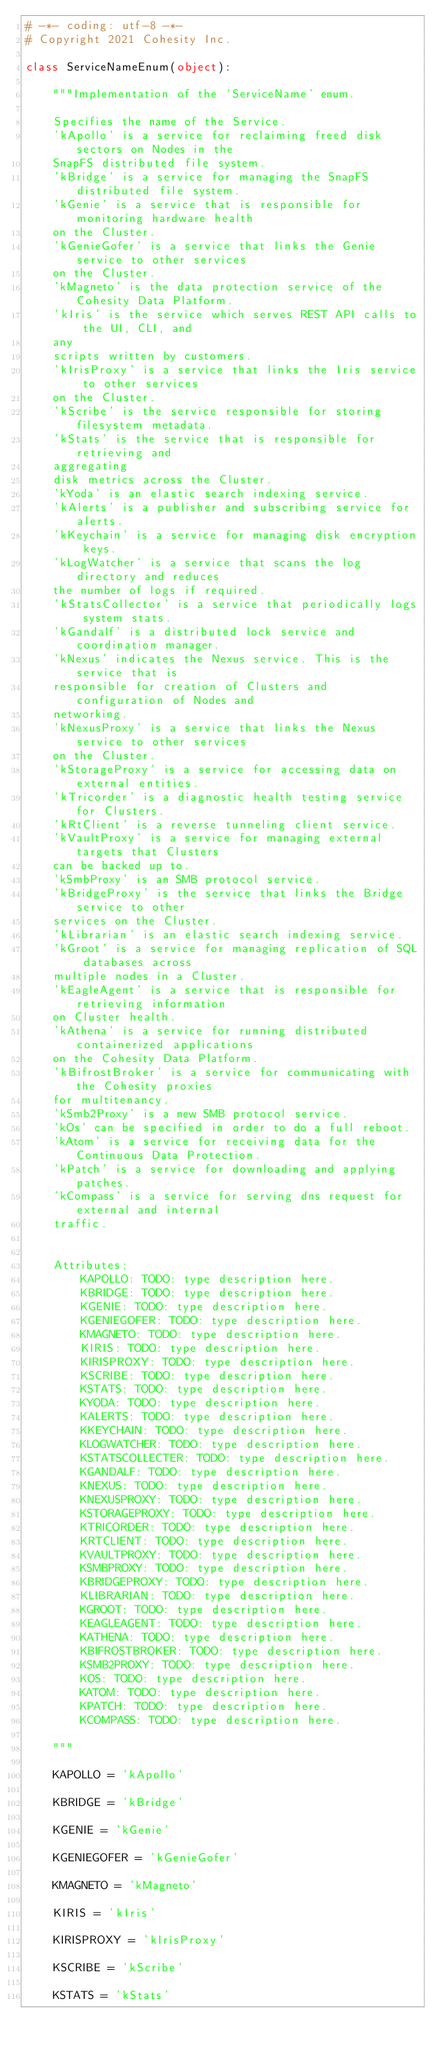<code> <loc_0><loc_0><loc_500><loc_500><_Python_># -*- coding: utf-8 -*-
# Copyright 2021 Cohesity Inc.

class ServiceNameEnum(object):

    """Implementation of the 'ServiceName' enum.

    Specifies the name of the Service.
    'kApollo' is a service for reclaiming freed disk sectors on Nodes in the
    SnapFS distributed file system.
    'kBridge' is a service for managing the SnapFS distributed file system.
    'kGenie' is a service that is responsible for monitoring hardware health
    on the Cluster.
    'kGenieGofer' is a service that links the Genie service to other services
    on the Cluster.
    'kMagneto' is the data protection service of the Cohesity Data Platform.
    'kIris' is the service which serves REST API calls to the UI, CLI, and
    any
    scripts written by customers.
    'kIrisProxy' is a service that links the Iris service to other services
    on the Cluster.
    'kScribe' is the service responsible for storing filesystem metadata.
    'kStats' is the service that is responsible for retrieving and
    aggregating
    disk metrics across the Cluster.
    'kYoda' is an elastic search indexing service.
    'kAlerts' is a publisher and subscribing service for alerts.
    'kKeychain' is a service for managing disk encryption keys.
    'kLogWatcher' is a service that scans the log directory and reduces
    the number of logs if required.
    'kStatsCollector' is a service that periodically logs system stats.
    'kGandalf' is a distributed lock service and coordination manager.
    'kNexus' indicates the Nexus service. This is the service that is
    responsible for creation of Clusters and configuration of Nodes and
    networking.
    'kNexusProxy' is a service that links the Nexus service to other services
    on the Cluster.
    'kStorageProxy' is a service for accessing data on external entities.
    'kTricorder' is a diagnostic health testing service for Clusters.
    'kRtClient' is a reverse tunneling client service.
    'kVaultProxy' is a service for managing external targets that Clusters
    can be backed up to.
    'kSmbProxy' is an SMB protocol service.
    'kBridgeProxy' is the service that links the Bridge service to other
    services on the Cluster.
    'kLibrarian' is an elastic search indexing service.
    'kGroot' is a service for managing replication of SQL databases across
    multiple nodes in a Cluster.
    'kEagleAgent' is a service that is responsible for retrieving information
    on Cluster health.
    'kAthena' is a service for running distributed containerized applications
    on the Cohesity Data Platform.
    'kBifrostBroker' is a service for communicating with the Cohesity proxies
    for multitenancy.
    'kSmb2Proxy' is a new SMB protocol service.
    'kOs' can be specified in order to do a full reboot.
    'kAtom' is a service for receiving data for the Continuous Data Protection.
    'kPatch' is a service for downloading and applying patches.
    'kCompass' is a service for serving dns request for external and internal
    traffic.


    Attributes:
        KAPOLLO: TODO: type description here.
        KBRIDGE: TODO: type description here.
        KGENIE: TODO: type description here.
        KGENIEGOFER: TODO: type description here.
        KMAGNETO: TODO: type description here.
        KIRIS: TODO: type description here.
        KIRISPROXY: TODO: type description here.
        KSCRIBE: TODO: type description here.
        KSTATS: TODO: type description here.
        KYODA: TODO: type description here.
        KALERTS: TODO: type description here.
        KKEYCHAIN: TODO: type description here.
        KLOGWATCHER: TODO: type description here.
        KSTATSCOLLECTER: TODO: type description here.
        KGANDALF: TODO: type description here.
        KNEXUS: TODO: type description here.
        KNEXUSPROXY: TODO: type description here.
        KSTORAGEPROXY: TODO: type description here.
        KTRICORDER: TODO: type description here.
        KRTCLIENT: TODO: type description here.
        KVAULTPROXY: TODO: type description here.
        KSMBPROXY: TODO: type description here.
        KBRIDGEPROXY: TODO: type description here.
        KLIBRARIAN: TODO: type description here.
        KGROOT: TODO: type description here.
        KEAGLEAGENT: TODO: type description here.
        KATHENA: TODO: type description here.
        KBIFROSTBROKER: TODO: type description here.
        KSMB2PROXY: TODO: type description here.
        KOS: TODO: type description here.
        KATOM: TODO: type description here.
        KPATCH: TODO: type description here.
        KCOMPASS: TODO: type description here.

    """

    KAPOLLO = 'kApollo'

    KBRIDGE = 'kBridge'

    KGENIE = 'kGenie'

    KGENIEGOFER = 'kGenieGofer'

    KMAGNETO = 'kMagneto'

    KIRIS = 'kIris'

    KIRISPROXY = 'kIrisProxy'

    KSCRIBE = 'kScribe'

    KSTATS = 'kStats'
</code> 